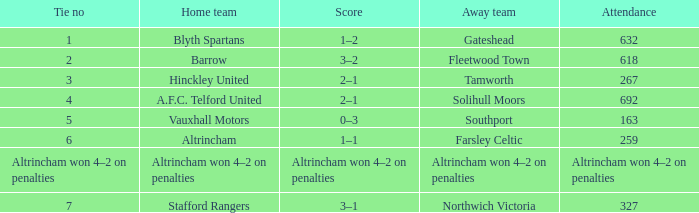Which away team that had a tie of 7? Northwich Victoria. 